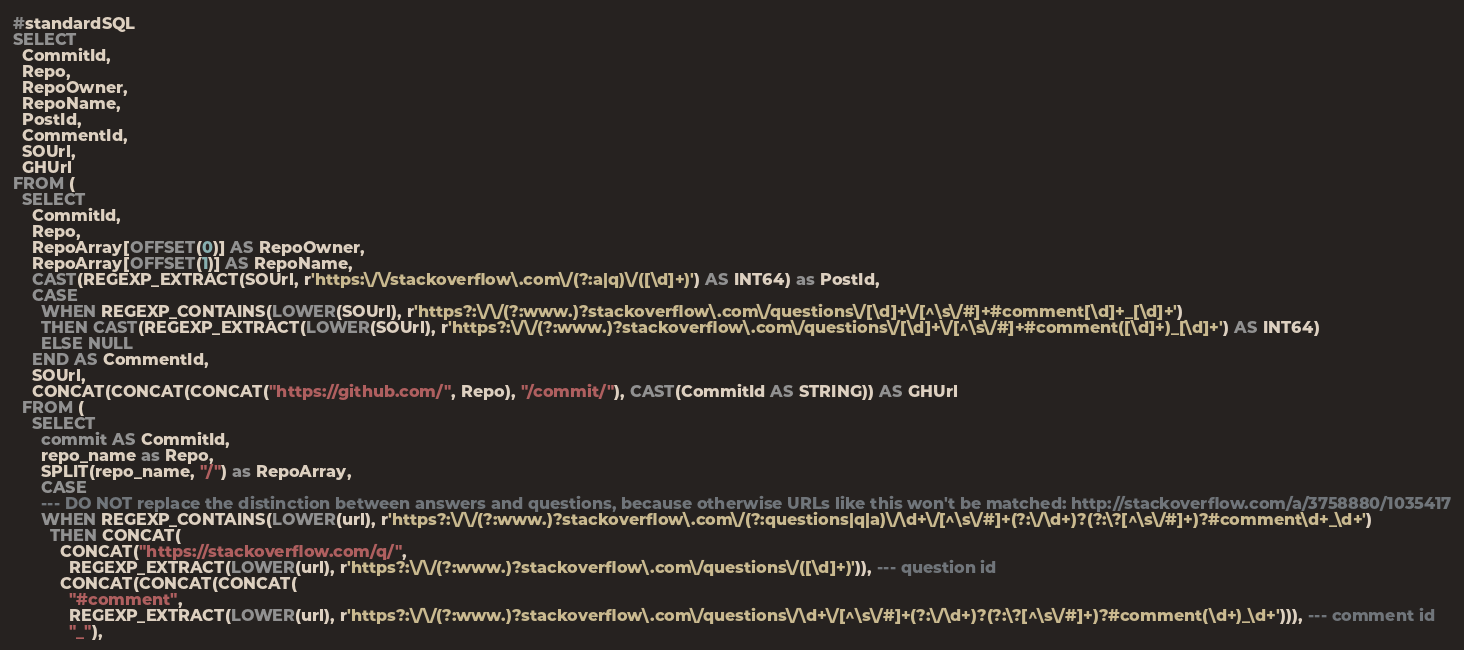<code> <loc_0><loc_0><loc_500><loc_500><_SQL_>#standardSQL
SELECT
  CommitId,
  Repo,
  RepoOwner,
  RepoName,
  PostId,
  CommentId,
  SOUrl,
  GHUrl
FROM (
  SELECT
    CommitId,
    Repo,
    RepoArray[OFFSET(0)] AS RepoOwner,
    RepoArray[OFFSET(1)] AS RepoName,
    CAST(REGEXP_EXTRACT(SOUrl, r'https:\/\/stackoverflow\.com\/(?:a|q)\/([\d]+)') AS INT64) as PostId,
    CASE
      WHEN REGEXP_CONTAINS(LOWER(SOUrl), r'https?:\/\/(?:www.)?stackoverflow\.com\/questions\/[\d]+\/[^\s\/#]+#comment[\d]+_[\d]+')
      THEN CAST(REGEXP_EXTRACT(LOWER(SOUrl), r'https?:\/\/(?:www.)?stackoverflow\.com\/questions\/[\d]+\/[^\s\/#]+#comment([\d]+)_[\d]+') AS INT64)
      ELSE NULL
    END AS CommentId,
    SOUrl,
    CONCAT(CONCAT(CONCAT("https://github.com/", Repo), "/commit/"), CAST(CommitId AS STRING)) AS GHUrl
  FROM (
    SELECT
      commit AS CommitId,
      repo_name as Repo,
      SPLIT(repo_name, "/") as RepoArray,
      CASE
      --- DO NOT replace the distinction between answers and questions, because otherwise URLs like this won't be matched: http://stackoverflow.com/a/3758880/1035417
      WHEN REGEXP_CONTAINS(LOWER(url), r'https?:\/\/(?:www.)?stackoverflow\.com\/(?:questions|q|a)\/\d+\/[^\s\/#]+(?:\/\d+)?(?:\?[^\s\/#]+)?#comment\d+_\d+')
        THEN CONCAT(
          CONCAT("https://stackoverflow.com/q/",
            REGEXP_EXTRACT(LOWER(url), r'https?:\/\/(?:www.)?stackoverflow\.com\/questions\/([\d]+)')), --- question id
          CONCAT(CONCAT(CONCAT(
            "#comment",
            REGEXP_EXTRACT(LOWER(url), r'https?:\/\/(?:www.)?stackoverflow\.com\/questions\/\d+\/[^\s\/#]+(?:\/\d+)?(?:\?[^\s\/#]+)?#comment(\d+)_\d+'))), --- comment id
            "_"),</code> 